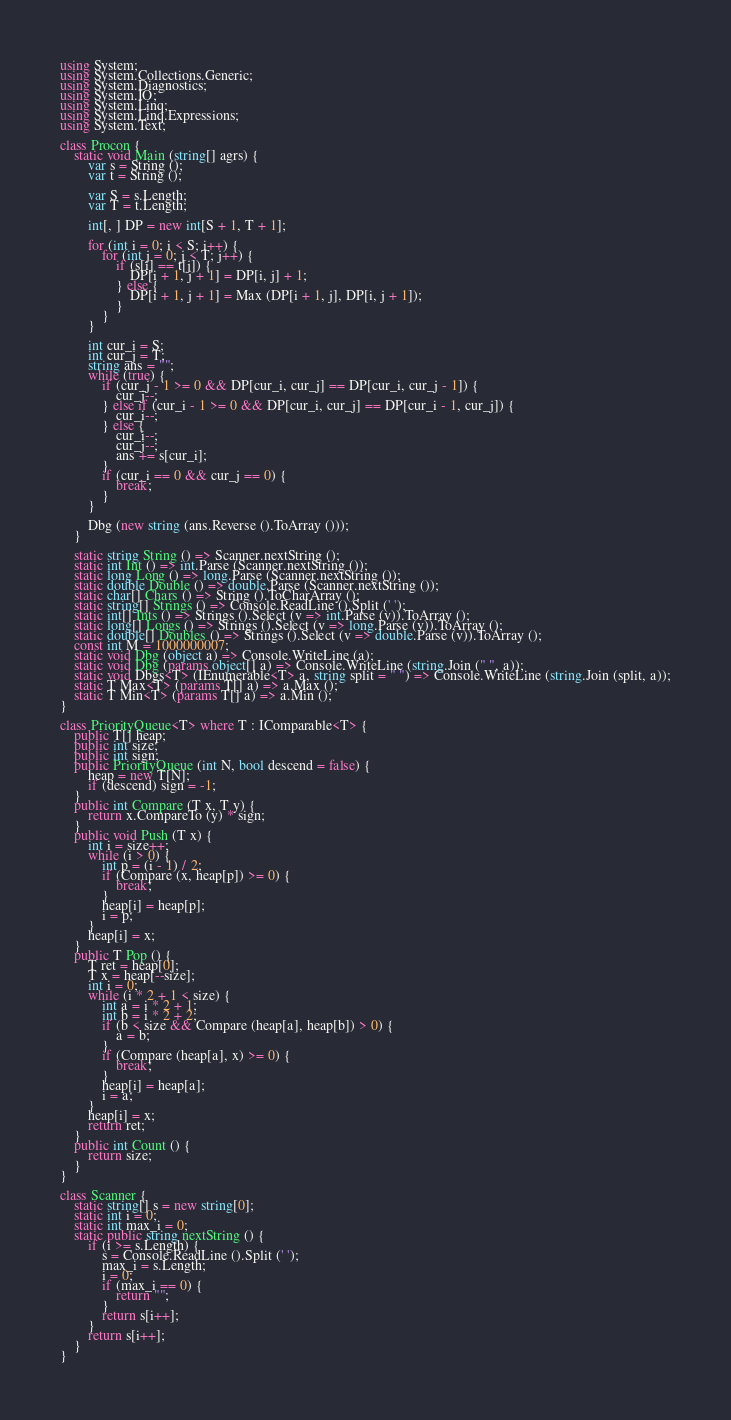Convert code to text. <code><loc_0><loc_0><loc_500><loc_500><_C#_>using System;
using System.Collections.Generic;
using System.Diagnostics;
using System.IO;
using System.Linq;
using System.Linq.Expressions;
using System.Text;

class Procon {
    static void Main (string[] agrs) {
        var s = String ();
        var t = String ();

        var S = s.Length;
        var T = t.Length;

        int[, ] DP = new int[S + 1, T + 1];

        for (int i = 0; i < S; i++) {
            for (int j = 0; j < T; j++) {
                if (s[i] == t[j]) {
                    DP[i + 1, j + 1] = DP[i, j] + 1;
                } else {
                    DP[i + 1, j + 1] = Max (DP[i + 1, j], DP[i, j + 1]);
                }
            }
        }

        int cur_i = S;
        int cur_j = T;
        string ans = "";
        while (true) {
            if (cur_j - 1 >= 0 && DP[cur_i, cur_j] == DP[cur_i, cur_j - 1]) {
                cur_j--;
            } else if (cur_i - 1 >= 0 && DP[cur_i, cur_j] == DP[cur_i - 1, cur_j]) {
                cur_i--;
            } else {
                cur_i--;
                cur_j--;
                ans += s[cur_i];
            }
            if (cur_i == 0 && cur_j == 0) {
                break;
            }
        }

        Dbg (new string (ans.Reverse ().ToArray ()));
    }

    static string String () => Scanner.nextString ();
    static int Int () => int.Parse (Scanner.nextString ());
    static long Long () => long.Parse (Scanner.nextString ());
    static double Double () => double.Parse (Scanner.nextString ());
    static char[] Chars () => String ().ToCharArray ();
    static string[] Strings () => Console.ReadLine ().Split (' ');
    static int[] Ints () => Strings ().Select (v => int.Parse (v)).ToArray ();
    static long[] Longs () => Strings ().Select (v => long.Parse (v)).ToArray ();
    static double[] Doubles () => Strings ().Select (v => double.Parse (v)).ToArray ();
    const int M = 1000000007;
    static void Dbg (object a) => Console.WriteLine (a);
    static void Dbg (params object[] a) => Console.WriteLine (string.Join (" ", a));
    static void Dbgs<T> (IEnumerable<T> a, string split = " ") => Console.WriteLine (string.Join (split, a));
    static T Max<T> (params T[] a) => a.Max ();
    static T Min<T> (params T[] a) => a.Min ();
}

class PriorityQueue<T> where T : IComparable<T> {
    public T[] heap;
    public int size;
    public int sign;
    public PriorityQueue (int N, bool descend = false) {
        heap = new T[N];
        if (descend) sign = -1;
    }
    public int Compare (T x, T y) {
        return x.CompareTo (y) * sign;
    }
    public void Push (T x) {
        int i = size++;
        while (i > 0) {
            int p = (i - 1) / 2;
            if (Compare (x, heap[p]) >= 0) {
                break;
            }
            heap[i] = heap[p];
            i = p;
        }
        heap[i] = x;
    }
    public T Pop () {
        T ret = heap[0];
        T x = heap[--size];
        int i = 0;
        while (i * 2 + 1 < size) {
            int a = i * 2 + 1;
            int b = i * 2 + 2;
            if (b < size && Compare (heap[a], heap[b]) > 0) {
                a = b;
            }
            if (Compare (heap[a], x) >= 0) {
                break;
            }
            heap[i] = heap[a];
            i = a;
        }
        heap[i] = x;
        return ret;
    }
    public int Count () {
        return size;
    }
}

class Scanner {
    static string[] s = new string[0];
    static int i = 0;
    static int max_i = 0;
    static public string nextString () {
        if (i >= s.Length) {
            s = Console.ReadLine ().Split (' ');
            max_i = s.Length;
            i = 0;
            if (max_i == 0) {
                return "";
            }
            return s[i++];
        }
        return s[i++];
    }
}</code> 